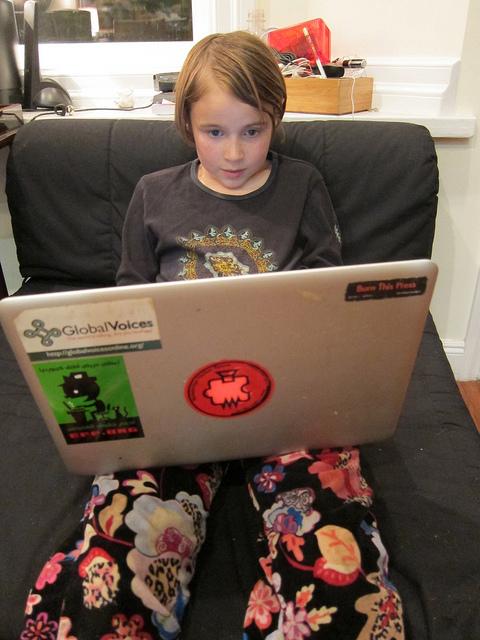Is the child holding a computer?
Keep it brief. Yes. What words are on the computer?
Give a very brief answer. Global voices. Is the child in pajamas?
Write a very short answer. Yes. 